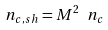<formula> <loc_0><loc_0><loc_500><loc_500>n _ { c , s h } = M ^ { 2 } \ n _ { c }</formula> 